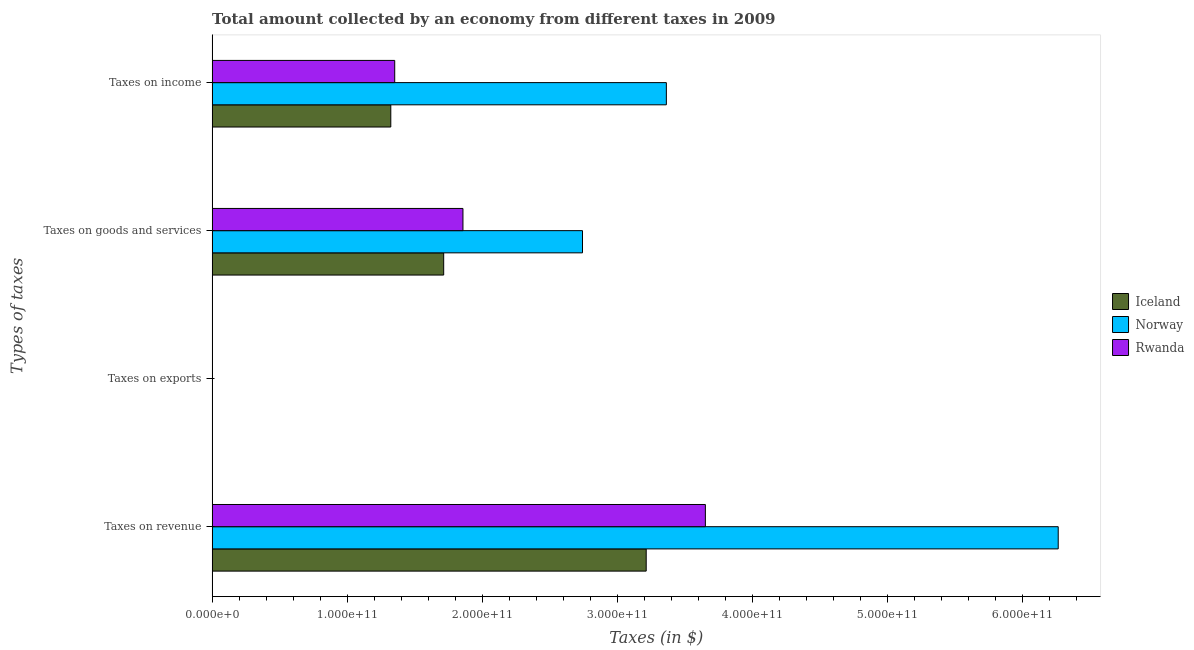Are the number of bars on each tick of the Y-axis equal?
Your answer should be compact. Yes. How many bars are there on the 1st tick from the top?
Keep it short and to the point. 3. How many bars are there on the 2nd tick from the bottom?
Make the answer very short. 3. What is the label of the 1st group of bars from the top?
Make the answer very short. Taxes on income. What is the amount collected as tax on goods in Iceland?
Give a very brief answer. 1.71e+11. Across all countries, what is the maximum amount collected as tax on revenue?
Your response must be concise. 6.26e+11. Across all countries, what is the minimum amount collected as tax on goods?
Provide a succinct answer. 1.71e+11. What is the total amount collected as tax on income in the graph?
Provide a succinct answer. 6.04e+11. What is the difference between the amount collected as tax on revenue in Norway and that in Rwanda?
Provide a short and direct response. 2.61e+11. What is the difference between the amount collected as tax on exports in Iceland and the amount collected as tax on revenue in Norway?
Provide a short and direct response. -6.26e+11. What is the average amount collected as tax on revenue per country?
Give a very brief answer. 4.38e+11. What is the difference between the amount collected as tax on revenue and amount collected as tax on goods in Rwanda?
Ensure brevity in your answer.  1.79e+11. What is the ratio of the amount collected as tax on exports in Rwanda to that in Norway?
Provide a succinct answer. 0.13. Is the difference between the amount collected as tax on goods in Rwanda and Iceland greater than the difference between the amount collected as tax on revenue in Rwanda and Iceland?
Provide a succinct answer. No. What is the difference between the highest and the second highest amount collected as tax on exports?
Your response must be concise. 1.13e+08. What is the difference between the highest and the lowest amount collected as tax on income?
Keep it short and to the point. 2.04e+11. Is it the case that in every country, the sum of the amount collected as tax on exports and amount collected as tax on income is greater than the sum of amount collected as tax on revenue and amount collected as tax on goods?
Your answer should be compact. No. What does the 3rd bar from the top in Taxes on revenue represents?
Give a very brief answer. Iceland. What does the 3rd bar from the bottom in Taxes on income represents?
Keep it short and to the point. Rwanda. How many countries are there in the graph?
Offer a terse response. 3. What is the difference between two consecutive major ticks on the X-axis?
Provide a succinct answer. 1.00e+11. Does the graph contain any zero values?
Keep it short and to the point. No. How many legend labels are there?
Make the answer very short. 3. How are the legend labels stacked?
Your answer should be very brief. Vertical. What is the title of the graph?
Keep it short and to the point. Total amount collected by an economy from different taxes in 2009. Does "Liberia" appear as one of the legend labels in the graph?
Provide a short and direct response. No. What is the label or title of the X-axis?
Your answer should be compact. Taxes (in $). What is the label or title of the Y-axis?
Provide a succinct answer. Types of taxes. What is the Taxes (in $) of Iceland in Taxes on revenue?
Provide a short and direct response. 3.21e+11. What is the Taxes (in $) in Norway in Taxes on revenue?
Keep it short and to the point. 6.26e+11. What is the Taxes (in $) in Rwanda in Taxes on revenue?
Offer a very short reply. 3.65e+11. What is the Taxes (in $) of Iceland in Taxes on exports?
Provide a short and direct response. 5.41e+06. What is the Taxes (in $) of Norway in Taxes on exports?
Your response must be concise. 1.30e+08. What is the Taxes (in $) of Rwanda in Taxes on exports?
Offer a terse response. 1.73e+07. What is the Taxes (in $) in Iceland in Taxes on goods and services?
Your response must be concise. 1.71e+11. What is the Taxes (in $) in Norway in Taxes on goods and services?
Provide a short and direct response. 2.74e+11. What is the Taxes (in $) of Rwanda in Taxes on goods and services?
Keep it short and to the point. 1.86e+11. What is the Taxes (in $) of Iceland in Taxes on income?
Your answer should be compact. 1.32e+11. What is the Taxes (in $) of Norway in Taxes on income?
Offer a terse response. 3.36e+11. What is the Taxes (in $) of Rwanda in Taxes on income?
Ensure brevity in your answer.  1.35e+11. Across all Types of taxes, what is the maximum Taxes (in $) in Iceland?
Offer a terse response. 3.21e+11. Across all Types of taxes, what is the maximum Taxes (in $) of Norway?
Provide a succinct answer. 6.26e+11. Across all Types of taxes, what is the maximum Taxes (in $) of Rwanda?
Offer a terse response. 3.65e+11. Across all Types of taxes, what is the minimum Taxes (in $) of Iceland?
Provide a short and direct response. 5.41e+06. Across all Types of taxes, what is the minimum Taxes (in $) of Norway?
Keep it short and to the point. 1.30e+08. Across all Types of taxes, what is the minimum Taxes (in $) of Rwanda?
Keep it short and to the point. 1.73e+07. What is the total Taxes (in $) in Iceland in the graph?
Keep it short and to the point. 6.25e+11. What is the total Taxes (in $) in Norway in the graph?
Ensure brevity in your answer.  1.24e+12. What is the total Taxes (in $) of Rwanda in the graph?
Offer a very short reply. 6.86e+11. What is the difference between the Taxes (in $) of Iceland in Taxes on revenue and that in Taxes on exports?
Ensure brevity in your answer.  3.21e+11. What is the difference between the Taxes (in $) in Norway in Taxes on revenue and that in Taxes on exports?
Your answer should be very brief. 6.26e+11. What is the difference between the Taxes (in $) in Rwanda in Taxes on revenue and that in Taxes on exports?
Provide a succinct answer. 3.65e+11. What is the difference between the Taxes (in $) of Iceland in Taxes on revenue and that in Taxes on goods and services?
Offer a terse response. 1.50e+11. What is the difference between the Taxes (in $) in Norway in Taxes on revenue and that in Taxes on goods and services?
Your answer should be compact. 3.52e+11. What is the difference between the Taxes (in $) of Rwanda in Taxes on revenue and that in Taxes on goods and services?
Ensure brevity in your answer.  1.79e+11. What is the difference between the Taxes (in $) in Iceland in Taxes on revenue and that in Taxes on income?
Give a very brief answer. 1.89e+11. What is the difference between the Taxes (in $) of Norway in Taxes on revenue and that in Taxes on income?
Provide a short and direct response. 2.90e+11. What is the difference between the Taxes (in $) in Rwanda in Taxes on revenue and that in Taxes on income?
Give a very brief answer. 2.30e+11. What is the difference between the Taxes (in $) in Iceland in Taxes on exports and that in Taxes on goods and services?
Provide a short and direct response. -1.71e+11. What is the difference between the Taxes (in $) in Norway in Taxes on exports and that in Taxes on goods and services?
Keep it short and to the point. -2.74e+11. What is the difference between the Taxes (in $) in Rwanda in Taxes on exports and that in Taxes on goods and services?
Make the answer very short. -1.86e+11. What is the difference between the Taxes (in $) of Iceland in Taxes on exports and that in Taxes on income?
Ensure brevity in your answer.  -1.32e+11. What is the difference between the Taxes (in $) of Norway in Taxes on exports and that in Taxes on income?
Make the answer very short. -3.36e+11. What is the difference between the Taxes (in $) in Rwanda in Taxes on exports and that in Taxes on income?
Provide a short and direct response. -1.35e+11. What is the difference between the Taxes (in $) in Iceland in Taxes on goods and services and that in Taxes on income?
Provide a succinct answer. 3.92e+1. What is the difference between the Taxes (in $) of Norway in Taxes on goods and services and that in Taxes on income?
Ensure brevity in your answer.  -6.21e+1. What is the difference between the Taxes (in $) in Rwanda in Taxes on goods and services and that in Taxes on income?
Your answer should be very brief. 5.05e+1. What is the difference between the Taxes (in $) of Iceland in Taxes on revenue and the Taxes (in $) of Norway in Taxes on exports?
Offer a terse response. 3.21e+11. What is the difference between the Taxes (in $) of Iceland in Taxes on revenue and the Taxes (in $) of Rwanda in Taxes on exports?
Provide a short and direct response. 3.21e+11. What is the difference between the Taxes (in $) in Norway in Taxes on revenue and the Taxes (in $) in Rwanda in Taxes on exports?
Make the answer very short. 6.26e+11. What is the difference between the Taxes (in $) in Iceland in Taxes on revenue and the Taxes (in $) in Norway in Taxes on goods and services?
Your answer should be very brief. 4.72e+1. What is the difference between the Taxes (in $) in Iceland in Taxes on revenue and the Taxes (in $) in Rwanda in Taxes on goods and services?
Provide a succinct answer. 1.36e+11. What is the difference between the Taxes (in $) of Norway in Taxes on revenue and the Taxes (in $) of Rwanda in Taxes on goods and services?
Make the answer very short. 4.41e+11. What is the difference between the Taxes (in $) in Iceland in Taxes on revenue and the Taxes (in $) in Norway in Taxes on income?
Your answer should be very brief. -1.49e+1. What is the difference between the Taxes (in $) of Iceland in Taxes on revenue and the Taxes (in $) of Rwanda in Taxes on income?
Your response must be concise. 1.86e+11. What is the difference between the Taxes (in $) of Norway in Taxes on revenue and the Taxes (in $) of Rwanda in Taxes on income?
Offer a very short reply. 4.91e+11. What is the difference between the Taxes (in $) in Iceland in Taxes on exports and the Taxes (in $) in Norway in Taxes on goods and services?
Provide a succinct answer. -2.74e+11. What is the difference between the Taxes (in $) of Iceland in Taxes on exports and the Taxes (in $) of Rwanda in Taxes on goods and services?
Your answer should be very brief. -1.86e+11. What is the difference between the Taxes (in $) in Norway in Taxes on exports and the Taxes (in $) in Rwanda in Taxes on goods and services?
Ensure brevity in your answer.  -1.86e+11. What is the difference between the Taxes (in $) in Iceland in Taxes on exports and the Taxes (in $) in Norway in Taxes on income?
Give a very brief answer. -3.36e+11. What is the difference between the Taxes (in $) in Iceland in Taxes on exports and the Taxes (in $) in Rwanda in Taxes on income?
Offer a very short reply. -1.35e+11. What is the difference between the Taxes (in $) of Norway in Taxes on exports and the Taxes (in $) of Rwanda in Taxes on income?
Provide a short and direct response. -1.35e+11. What is the difference between the Taxes (in $) in Iceland in Taxes on goods and services and the Taxes (in $) in Norway in Taxes on income?
Keep it short and to the point. -1.65e+11. What is the difference between the Taxes (in $) in Iceland in Taxes on goods and services and the Taxes (in $) in Rwanda in Taxes on income?
Your answer should be very brief. 3.62e+1. What is the difference between the Taxes (in $) of Norway in Taxes on goods and services and the Taxes (in $) of Rwanda in Taxes on income?
Provide a succinct answer. 1.39e+11. What is the average Taxes (in $) in Iceland per Types of taxes?
Provide a short and direct response. 1.56e+11. What is the average Taxes (in $) in Norway per Types of taxes?
Your answer should be very brief. 3.09e+11. What is the average Taxes (in $) in Rwanda per Types of taxes?
Give a very brief answer. 1.72e+11. What is the difference between the Taxes (in $) of Iceland and Taxes (in $) of Norway in Taxes on revenue?
Your answer should be very brief. -3.05e+11. What is the difference between the Taxes (in $) in Iceland and Taxes (in $) in Rwanda in Taxes on revenue?
Keep it short and to the point. -4.38e+1. What is the difference between the Taxes (in $) of Norway and Taxes (in $) of Rwanda in Taxes on revenue?
Give a very brief answer. 2.61e+11. What is the difference between the Taxes (in $) of Iceland and Taxes (in $) of Norway in Taxes on exports?
Your answer should be compact. -1.25e+08. What is the difference between the Taxes (in $) in Iceland and Taxes (in $) in Rwanda in Taxes on exports?
Offer a terse response. -1.19e+07. What is the difference between the Taxes (in $) of Norway and Taxes (in $) of Rwanda in Taxes on exports?
Your answer should be compact. 1.13e+08. What is the difference between the Taxes (in $) of Iceland and Taxes (in $) of Norway in Taxes on goods and services?
Provide a succinct answer. -1.03e+11. What is the difference between the Taxes (in $) of Iceland and Taxes (in $) of Rwanda in Taxes on goods and services?
Your response must be concise. -1.43e+1. What is the difference between the Taxes (in $) of Norway and Taxes (in $) of Rwanda in Taxes on goods and services?
Your answer should be very brief. 8.85e+1. What is the difference between the Taxes (in $) in Iceland and Taxes (in $) in Norway in Taxes on income?
Make the answer very short. -2.04e+11. What is the difference between the Taxes (in $) of Iceland and Taxes (in $) of Rwanda in Taxes on income?
Your response must be concise. -2.91e+09. What is the difference between the Taxes (in $) in Norway and Taxes (in $) in Rwanda in Taxes on income?
Provide a short and direct response. 2.01e+11. What is the ratio of the Taxes (in $) of Iceland in Taxes on revenue to that in Taxes on exports?
Keep it short and to the point. 5.94e+04. What is the ratio of the Taxes (in $) of Norway in Taxes on revenue to that in Taxes on exports?
Your answer should be very brief. 4818.38. What is the ratio of the Taxes (in $) of Rwanda in Taxes on revenue to that in Taxes on exports?
Offer a very short reply. 2.11e+04. What is the ratio of the Taxes (in $) of Iceland in Taxes on revenue to that in Taxes on goods and services?
Offer a terse response. 1.87. What is the ratio of the Taxes (in $) in Norway in Taxes on revenue to that in Taxes on goods and services?
Keep it short and to the point. 2.28. What is the ratio of the Taxes (in $) in Rwanda in Taxes on revenue to that in Taxes on goods and services?
Your response must be concise. 1.97. What is the ratio of the Taxes (in $) in Iceland in Taxes on revenue to that in Taxes on income?
Your response must be concise. 2.43. What is the ratio of the Taxes (in $) in Norway in Taxes on revenue to that in Taxes on income?
Your answer should be compact. 1.86. What is the ratio of the Taxes (in $) of Rwanda in Taxes on revenue to that in Taxes on income?
Ensure brevity in your answer.  2.7. What is the ratio of the Taxes (in $) in Norway in Taxes on exports to that in Taxes on goods and services?
Give a very brief answer. 0. What is the ratio of the Taxes (in $) in Rwanda in Taxes on exports to that in Taxes on goods and services?
Keep it short and to the point. 0. What is the ratio of the Taxes (in $) in Iceland in Taxes on exports to that in Taxes on income?
Give a very brief answer. 0. What is the ratio of the Taxes (in $) in Iceland in Taxes on goods and services to that in Taxes on income?
Provide a short and direct response. 1.3. What is the ratio of the Taxes (in $) of Norway in Taxes on goods and services to that in Taxes on income?
Provide a succinct answer. 0.82. What is the ratio of the Taxes (in $) of Rwanda in Taxes on goods and services to that in Taxes on income?
Give a very brief answer. 1.37. What is the difference between the highest and the second highest Taxes (in $) of Iceland?
Keep it short and to the point. 1.50e+11. What is the difference between the highest and the second highest Taxes (in $) in Norway?
Make the answer very short. 2.90e+11. What is the difference between the highest and the second highest Taxes (in $) in Rwanda?
Make the answer very short. 1.79e+11. What is the difference between the highest and the lowest Taxes (in $) in Iceland?
Make the answer very short. 3.21e+11. What is the difference between the highest and the lowest Taxes (in $) in Norway?
Your answer should be compact. 6.26e+11. What is the difference between the highest and the lowest Taxes (in $) in Rwanda?
Keep it short and to the point. 3.65e+11. 